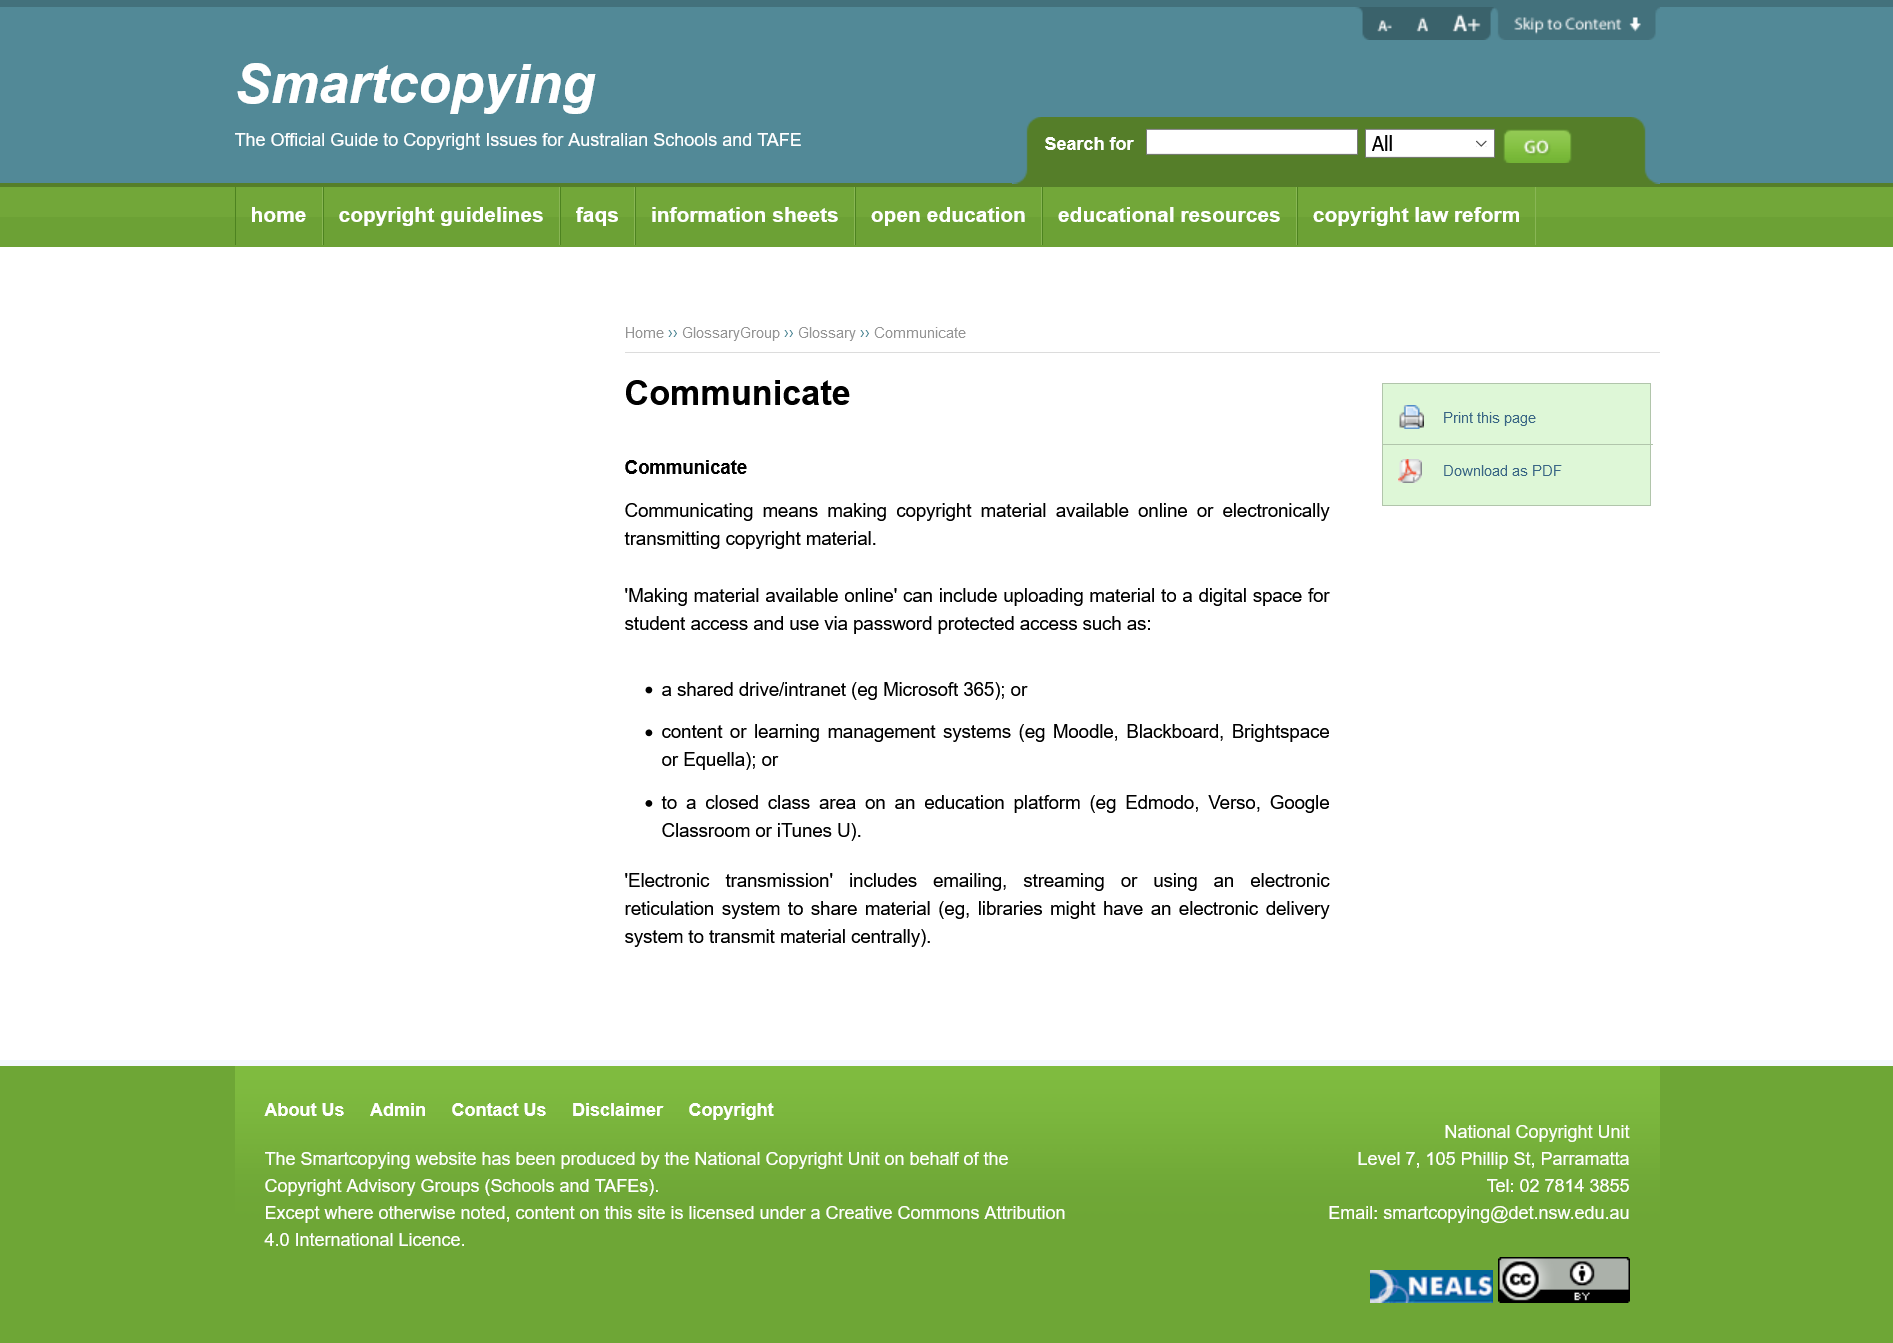Specify some key components in this picture. It is not considered making material available online by simply printing out class notes and distributing them to students. Microsoft 365 is an example of a shared drive or intranet. Sending material via email constitutes communication. 